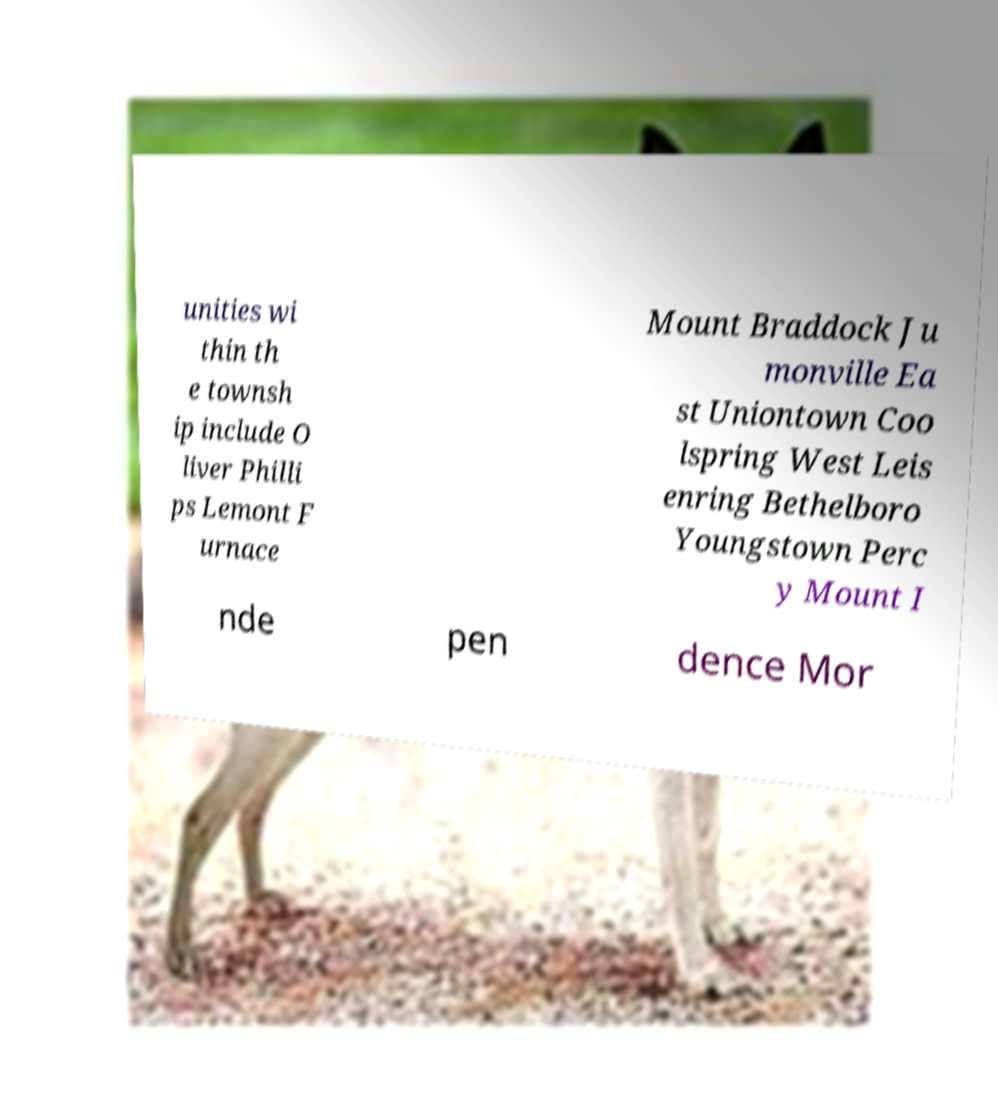Please read and relay the text visible in this image. What does it say? unities wi thin th e townsh ip include O liver Philli ps Lemont F urnace Mount Braddock Ju monville Ea st Uniontown Coo lspring West Leis enring Bethelboro Youngstown Perc y Mount I nde pen dence Mor 